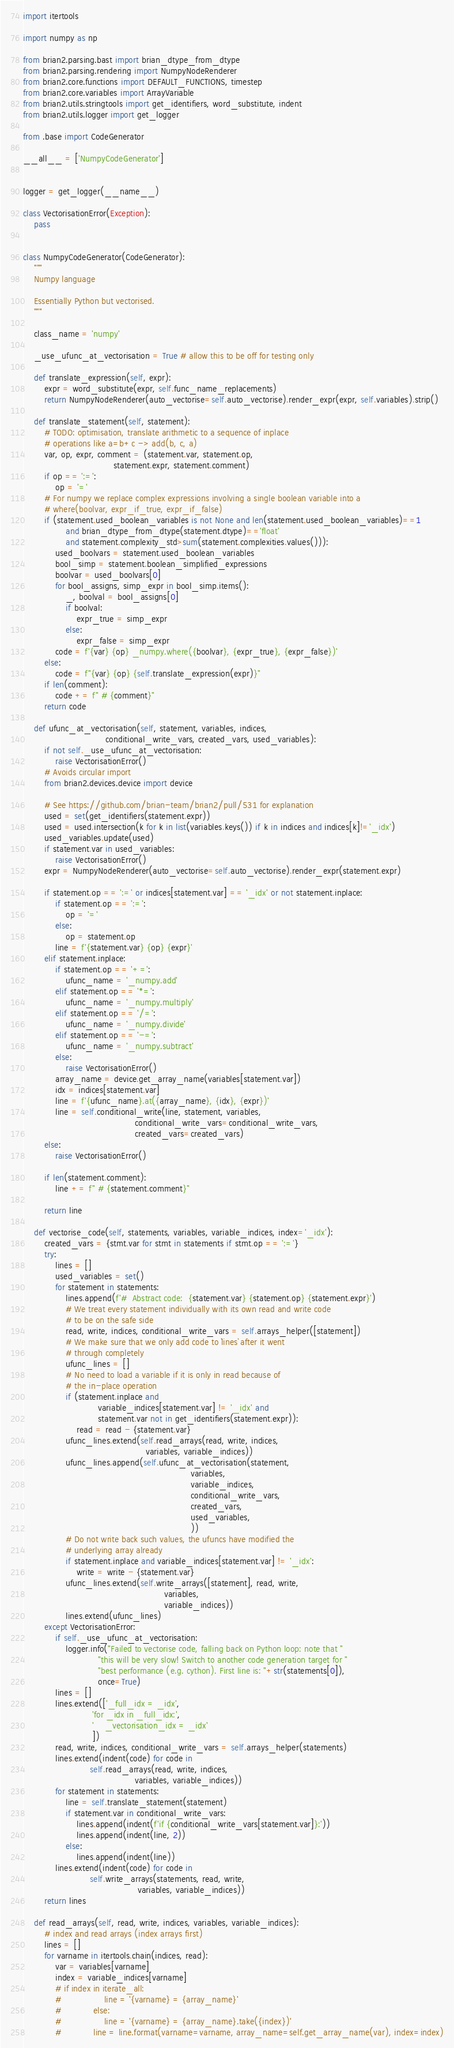Convert code to text. <code><loc_0><loc_0><loc_500><loc_500><_Python_>
import itertools

import numpy as np

from brian2.parsing.bast import brian_dtype_from_dtype
from brian2.parsing.rendering import NumpyNodeRenderer
from brian2.core.functions import DEFAULT_FUNCTIONS, timestep
from brian2.core.variables import ArrayVariable
from brian2.utils.stringtools import get_identifiers, word_substitute, indent
from brian2.utils.logger import get_logger

from .base import CodeGenerator

__all__ = ['NumpyCodeGenerator']


logger = get_logger(__name__)

class VectorisationError(Exception):
    pass


class NumpyCodeGenerator(CodeGenerator):
    """
    Numpy language
    
    Essentially Python but vectorised.
    """

    class_name = 'numpy'

    _use_ufunc_at_vectorisation = True # allow this to be off for testing only

    def translate_expression(self, expr):
        expr = word_substitute(expr, self.func_name_replacements)
        return NumpyNodeRenderer(auto_vectorise=self.auto_vectorise).render_expr(expr, self.variables).strip()

    def translate_statement(self, statement):
        # TODO: optimisation, translate arithmetic to a sequence of inplace
        # operations like a=b+c -> add(b, c, a)
        var, op, expr, comment = (statement.var, statement.op,
                                  statement.expr, statement.comment)
        if op == ':=':
            op = '='
        # For numpy we replace complex expressions involving a single boolean variable into a
        # where(boolvar, expr_if_true, expr_if_false)
        if (statement.used_boolean_variables is not None and len(statement.used_boolean_variables)==1
                and brian_dtype_from_dtype(statement.dtype)=='float'
                and statement.complexity_std>sum(statement.complexities.values())):
            used_boolvars = statement.used_boolean_variables
            bool_simp = statement.boolean_simplified_expressions
            boolvar = used_boolvars[0]
            for bool_assigns, simp_expr in bool_simp.items():
                _, boolval = bool_assigns[0]
                if boolval:
                    expr_true = simp_expr
                else:
                    expr_false = simp_expr
            code = f'{var} {op} _numpy.where({boolvar}, {expr_true}, {expr_false})'
        else:
            code = f"{var} {op} {self.translate_expression(expr)}"
        if len(comment):
            code += f" # {comment}"
        return code

    def ufunc_at_vectorisation(self, statement, variables, indices,
                               conditional_write_vars, created_vars, used_variables):
        if not self._use_ufunc_at_vectorisation:
            raise VectorisationError()
        # Avoids circular import
        from brian2.devices.device import device

        # See https://github.com/brian-team/brian2/pull/531 for explanation
        used = set(get_identifiers(statement.expr))
        used = used.intersection(k for k in list(variables.keys()) if k in indices and indices[k]!='_idx')
        used_variables.update(used)
        if statement.var in used_variables:
            raise VectorisationError()
        expr = NumpyNodeRenderer(auto_vectorise=self.auto_vectorise).render_expr(statement.expr)

        if statement.op == ':=' or indices[statement.var] == '_idx' or not statement.inplace:
            if statement.op == ':=':
                op = '='
            else:
                op = statement.op
            line = f'{statement.var} {op} {expr}'
        elif statement.inplace:
            if statement.op == '+=':
                ufunc_name = '_numpy.add'
            elif statement.op == '*=':
                ufunc_name = '_numpy.multiply'
            elif statement.op == '/=':
                ufunc_name = '_numpy.divide'
            elif statement.op == '-=':
                ufunc_name = '_numpy.subtract'
            else:
                raise VectorisationError()
            array_name = device.get_array_name(variables[statement.var])
            idx = indices[statement.var]
            line = f'{ufunc_name}.at({array_name}, {idx}, {expr})'
            line = self.conditional_write(line, statement, variables,
                                          conditional_write_vars=conditional_write_vars,
                                          created_vars=created_vars)
        else:
            raise VectorisationError()

        if len(statement.comment):
            line += f" # {statement.comment}"

        return line

    def vectorise_code(self, statements, variables, variable_indices, index='_idx'):
        created_vars = {stmt.var for stmt in statements if stmt.op == ':='}
        try:
            lines = []
            used_variables = set()
            for statement in statements:
                lines.append(f'#  Abstract code:  {statement.var} {statement.op} {statement.expr}')
                # We treat every statement individually with its own read and write code
                # to be on the safe side
                read, write, indices, conditional_write_vars = self.arrays_helper([statement])
                # We make sure that we only add code to `lines` after it went
                # through completely
                ufunc_lines = []
                # No need to load a variable if it is only in read because of
                # the in-place operation
                if (statement.inplace and
                            variable_indices[statement.var] != '_idx' and
                            statement.var not in get_identifiers(statement.expr)):
                    read = read - {statement.var}
                ufunc_lines.extend(self.read_arrays(read, write, indices,
                                              variables, variable_indices))
                ufunc_lines.append(self.ufunc_at_vectorisation(statement,
                                                               variables,
                                                               variable_indices,
                                                               conditional_write_vars,
                                                               created_vars,
                                                               used_variables,
                                                               ))
                # Do not write back such values, the ufuncs have modified the
                # underlying array already
                if statement.inplace and variable_indices[statement.var] != '_idx':
                    write = write - {statement.var}
                ufunc_lines.extend(self.write_arrays([statement], read, write,
                                                     variables,
                                                     variable_indices))
                lines.extend(ufunc_lines)
        except VectorisationError:
            if self._use_ufunc_at_vectorisation:
                logger.info("Failed to vectorise code, falling back on Python loop: note that "
                            "this will be very slow! Switch to another code generation target for "
                            "best performance (e.g. cython). First line is: "+str(statements[0]),
                            once=True)
            lines = []
            lines.extend(['_full_idx = _idx',
                          'for _idx in _full_idx:',
                          '    _vectorisation_idx = _idx'
                          ])
            read, write, indices, conditional_write_vars = self.arrays_helper(statements)
            lines.extend(indent(code) for code in
                         self.read_arrays(read, write, indices,
                                          variables, variable_indices))
            for statement in statements:
                line = self.translate_statement(statement)
                if statement.var in conditional_write_vars:
                    lines.append(indent(f'if {conditional_write_vars[statement.var]}:'))
                    lines.append(indent(line, 2))
                else:
                    lines.append(indent(line))
            lines.extend(indent(code) for code in
                         self.write_arrays(statements, read, write,
                                           variables, variable_indices))
        return lines

    def read_arrays(self, read, write, indices, variables, variable_indices):
        # index and read arrays (index arrays first)
        lines = []
        for varname in itertools.chain(indices, read):
            var = variables[varname]
            index = variable_indices[varname]
            # if index in iterate_all:
            #                line = '{varname} = {array_name}'
            #            else:
            #                line = '{varname} = {array_name}.take({index})'
            #            line = line.format(varname=varname, array_name=self.get_array_name(var), index=index)</code> 